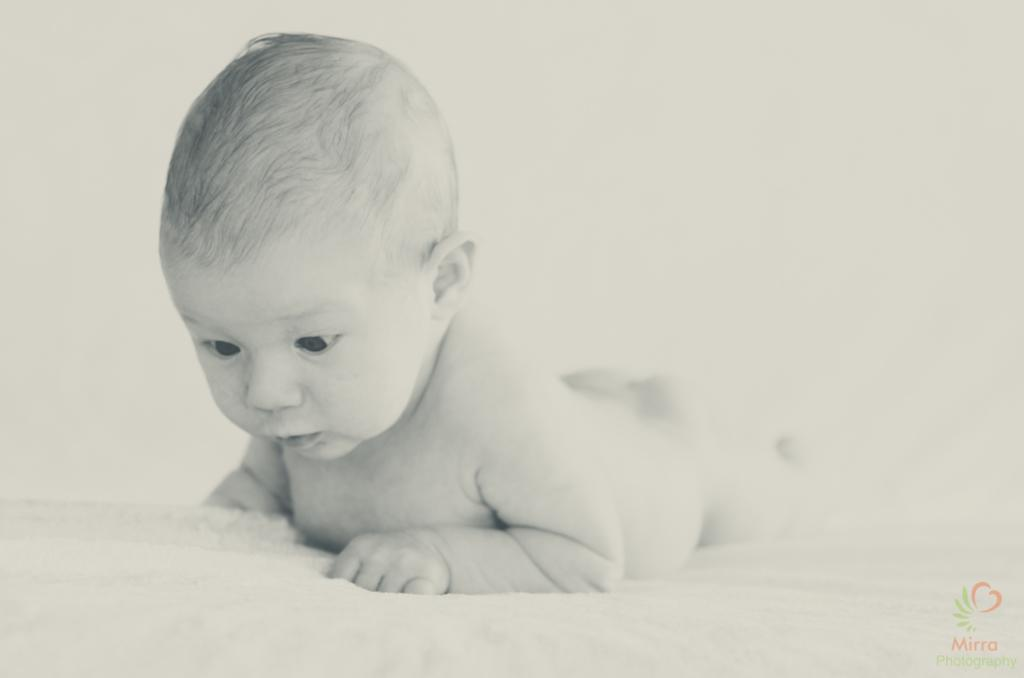What is the main subject of the image? The main subject of the image is a person lying on a surface. What can be said about the color scheme of the image? The image is black and white. What type of food is the person eating in the image? There is no indication in the image that the person is eating any food, so it cannot be determined from the picture. 